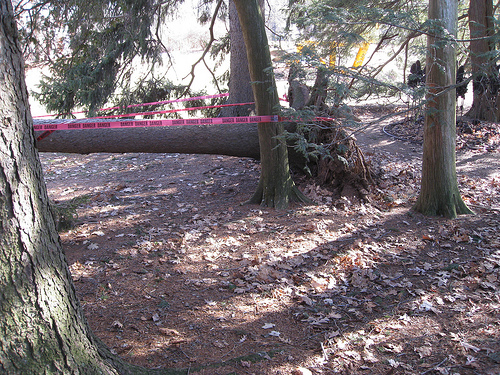<image>
Is there a tree in the ground? No. The tree is not contained within the ground. These objects have a different spatial relationship. Where is the tree in relation to the tree? Is it next to the tree? Yes. The tree is positioned adjacent to the tree, located nearby in the same general area. 